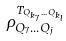Convert formula to latex. <formula><loc_0><loc_0><loc_500><loc_500>\rho _ { Q _ { 7 } \dots Q _ { j } } ^ { T _ { Q _ { k _ { 7 } } \dots Q _ { k _ { l } } } }</formula> 